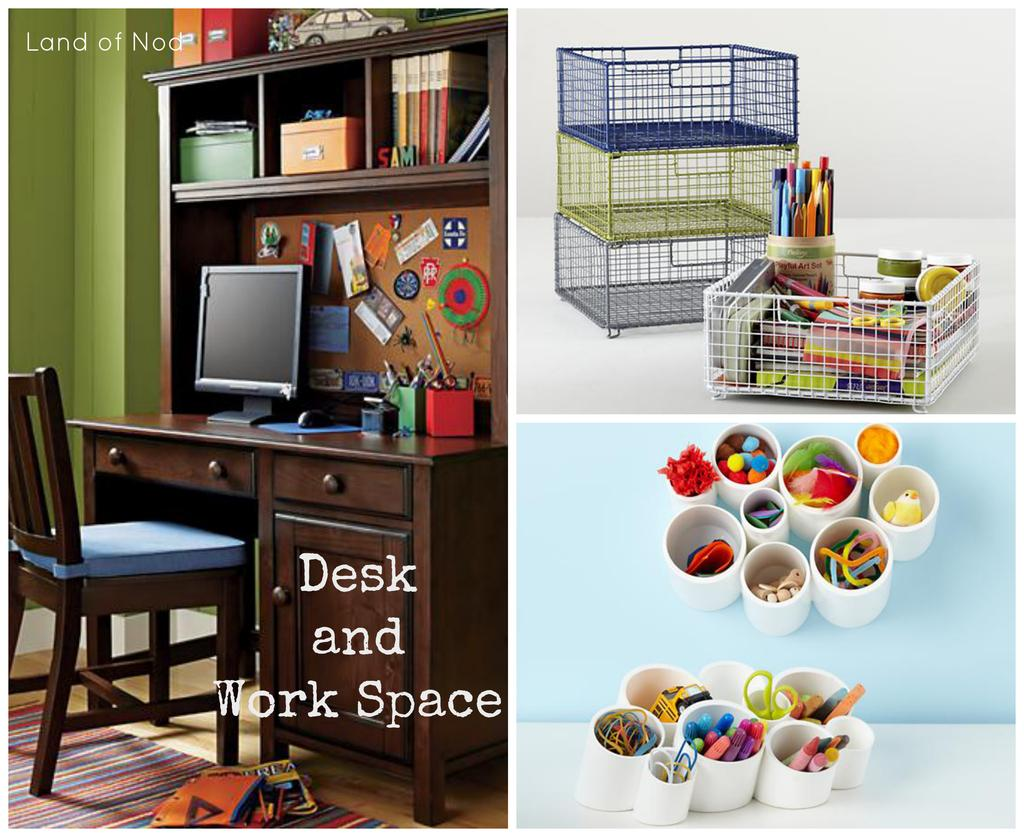<image>
Summarize the visual content of the image. Desk and work space ideas are brought to you from the Land of Nod. 